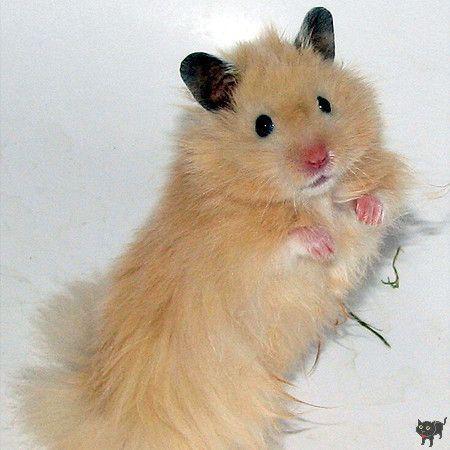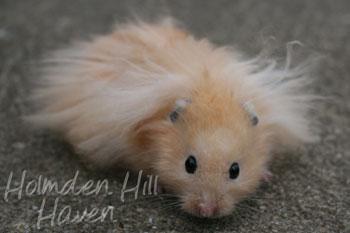The first image is the image on the left, the second image is the image on the right. Evaluate the accuracy of this statement regarding the images: "There is a hamster eating a piece of broccoli.". Is it true? Answer yes or no. No. The first image is the image on the left, the second image is the image on the right. Considering the images on both sides, is "A light orange hamster is holding a broccoli floret to its mouth with both front paws." valid? Answer yes or no. No. 